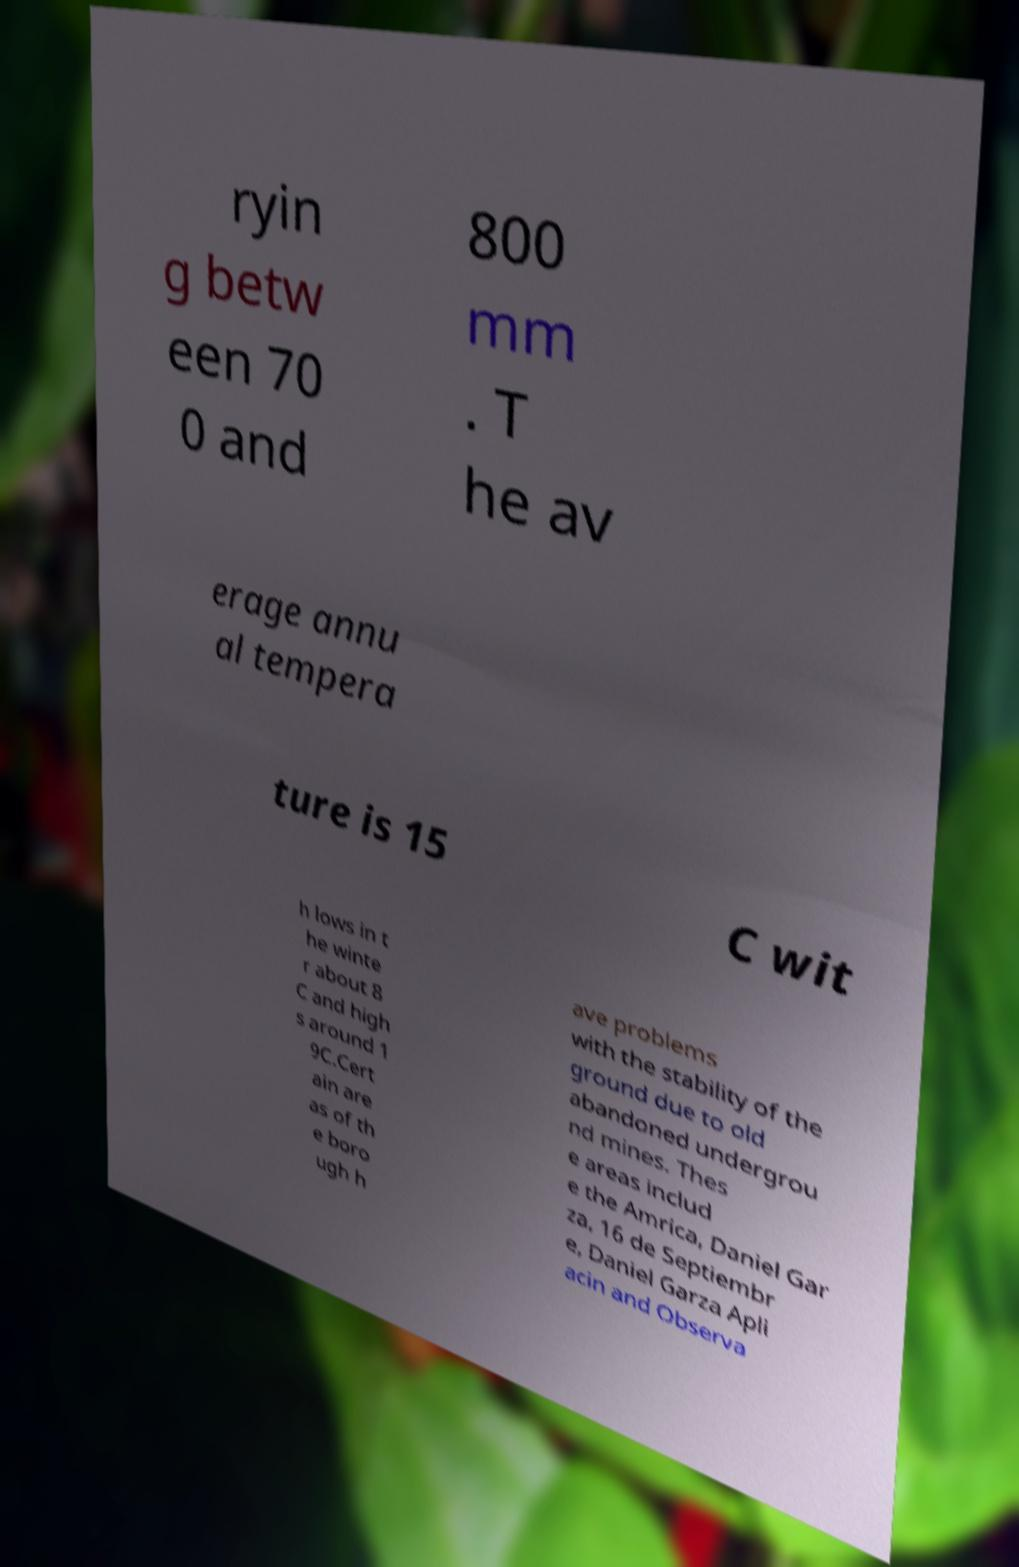There's text embedded in this image that I need extracted. Can you transcribe it verbatim? ryin g betw een 70 0 and 800 mm . T he av erage annu al tempera ture is 15 C wit h lows in t he winte r about 8 C and high s around 1 9C.Cert ain are as of th e boro ugh h ave problems with the stability of the ground due to old abandoned undergrou nd mines. Thes e areas includ e the Amrica, Daniel Gar za, 16 de Septiembr e, Daniel Garza Apli acin and Observa 